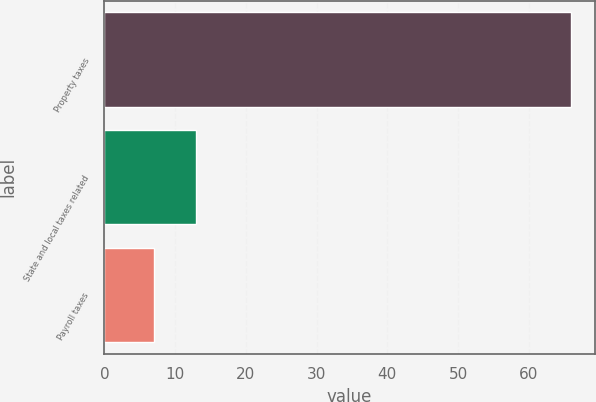Convert chart to OTSL. <chart><loc_0><loc_0><loc_500><loc_500><bar_chart><fcel>Property taxes<fcel>State and local taxes related<fcel>Payroll taxes<nl><fcel>66<fcel>12.9<fcel>7<nl></chart> 